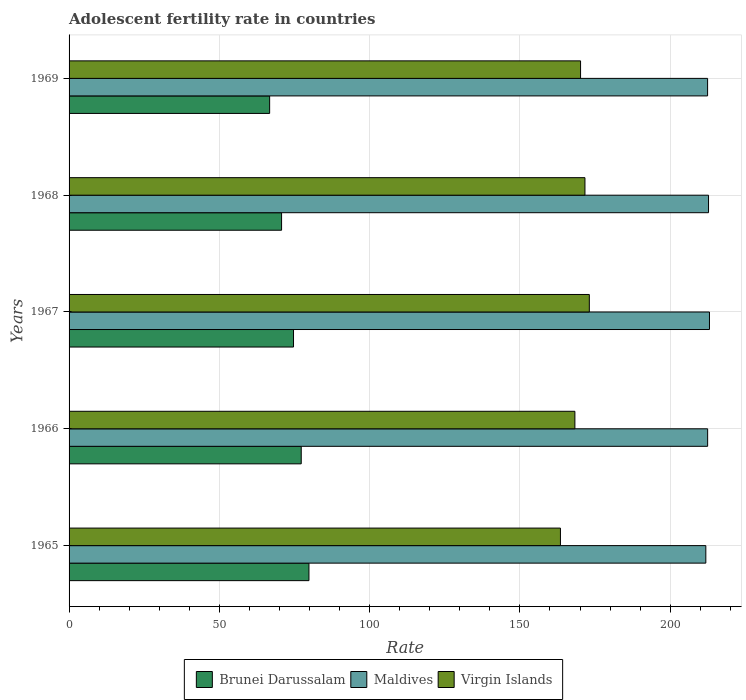Are the number of bars per tick equal to the number of legend labels?
Ensure brevity in your answer.  Yes. Are the number of bars on each tick of the Y-axis equal?
Give a very brief answer. Yes. How many bars are there on the 2nd tick from the bottom?
Give a very brief answer. 3. What is the label of the 1st group of bars from the top?
Offer a terse response. 1969. In how many cases, is the number of bars for a given year not equal to the number of legend labels?
Your answer should be very brief. 0. What is the adolescent fertility rate in Virgin Islands in 1965?
Your answer should be very brief. 163.49. Across all years, what is the maximum adolescent fertility rate in Maldives?
Give a very brief answer. 213.08. Across all years, what is the minimum adolescent fertility rate in Virgin Islands?
Give a very brief answer. 163.49. In which year was the adolescent fertility rate in Maldives maximum?
Offer a terse response. 1967. In which year was the adolescent fertility rate in Virgin Islands minimum?
Ensure brevity in your answer.  1965. What is the total adolescent fertility rate in Maldives in the graph?
Ensure brevity in your answer.  1062.65. What is the difference between the adolescent fertility rate in Maldives in 1965 and that in 1969?
Provide a succinct answer. -0.59. What is the difference between the adolescent fertility rate in Virgin Islands in 1967 and the adolescent fertility rate in Brunei Darussalam in 1968?
Ensure brevity in your answer.  102.4. What is the average adolescent fertility rate in Maldives per year?
Ensure brevity in your answer.  212.53. In the year 1966, what is the difference between the adolescent fertility rate in Brunei Darussalam and adolescent fertility rate in Virgin Islands?
Keep it short and to the point. -91.05. What is the ratio of the adolescent fertility rate in Maldives in 1966 to that in 1969?
Keep it short and to the point. 1. Is the adolescent fertility rate in Brunei Darussalam in 1965 less than that in 1966?
Your answer should be compact. No. Is the difference between the adolescent fertility rate in Brunei Darussalam in 1966 and 1969 greater than the difference between the adolescent fertility rate in Virgin Islands in 1966 and 1969?
Offer a terse response. Yes. What is the difference between the highest and the second highest adolescent fertility rate in Virgin Islands?
Ensure brevity in your answer.  1.46. What is the difference between the highest and the lowest adolescent fertility rate in Maldives?
Keep it short and to the point. 1.21. In how many years, is the adolescent fertility rate in Virgin Islands greater than the average adolescent fertility rate in Virgin Islands taken over all years?
Provide a succinct answer. 3. What does the 3rd bar from the top in 1969 represents?
Make the answer very short. Brunei Darussalam. What does the 2nd bar from the bottom in 1969 represents?
Keep it short and to the point. Maldives. Are all the bars in the graph horizontal?
Your response must be concise. Yes. How many years are there in the graph?
Provide a succinct answer. 5. Are the values on the major ticks of X-axis written in scientific E-notation?
Offer a terse response. No. Does the graph contain grids?
Keep it short and to the point. Yes. Where does the legend appear in the graph?
Your answer should be compact. Bottom center. How many legend labels are there?
Provide a succinct answer. 3. What is the title of the graph?
Make the answer very short. Adolescent fertility rate in countries. What is the label or title of the X-axis?
Your answer should be very brief. Rate. What is the label or title of the Y-axis?
Offer a terse response. Years. What is the Rate of Brunei Darussalam in 1965?
Keep it short and to the point. 79.82. What is the Rate in Maldives in 1965?
Your answer should be very brief. 211.87. What is the Rate of Virgin Islands in 1965?
Your answer should be compact. 163.49. What is the Rate of Brunei Darussalam in 1966?
Your response must be concise. 77.25. What is the Rate of Maldives in 1966?
Your answer should be compact. 212.47. What is the Rate in Virgin Islands in 1966?
Offer a terse response. 168.3. What is the Rate in Brunei Darussalam in 1967?
Your answer should be very brief. 74.68. What is the Rate of Maldives in 1967?
Provide a short and direct response. 213.08. What is the Rate in Virgin Islands in 1967?
Provide a succinct answer. 173.11. What is the Rate of Brunei Darussalam in 1968?
Give a very brief answer. 70.71. What is the Rate of Maldives in 1968?
Your response must be concise. 212.77. What is the Rate of Virgin Islands in 1968?
Offer a very short reply. 171.65. What is the Rate in Brunei Darussalam in 1969?
Keep it short and to the point. 66.74. What is the Rate of Maldives in 1969?
Your response must be concise. 212.46. What is the Rate of Virgin Islands in 1969?
Your response must be concise. 170.19. Across all years, what is the maximum Rate of Brunei Darussalam?
Keep it short and to the point. 79.82. Across all years, what is the maximum Rate of Maldives?
Your answer should be compact. 213.08. Across all years, what is the maximum Rate of Virgin Islands?
Make the answer very short. 173.11. Across all years, what is the minimum Rate of Brunei Darussalam?
Offer a very short reply. 66.74. Across all years, what is the minimum Rate of Maldives?
Your answer should be compact. 211.87. Across all years, what is the minimum Rate in Virgin Islands?
Keep it short and to the point. 163.49. What is the total Rate in Brunei Darussalam in the graph?
Give a very brief answer. 369.19. What is the total Rate of Maldives in the graph?
Your answer should be compact. 1062.65. What is the total Rate of Virgin Islands in the graph?
Your answer should be compact. 846.74. What is the difference between the Rate in Brunei Darussalam in 1965 and that in 1966?
Give a very brief answer. 2.57. What is the difference between the Rate in Maldives in 1965 and that in 1966?
Provide a succinct answer. -0.61. What is the difference between the Rate of Virgin Islands in 1965 and that in 1966?
Provide a short and direct response. -4.81. What is the difference between the Rate of Brunei Darussalam in 1965 and that in 1967?
Your answer should be very brief. 5.13. What is the difference between the Rate of Maldives in 1965 and that in 1967?
Offer a very short reply. -1.21. What is the difference between the Rate in Virgin Islands in 1965 and that in 1967?
Provide a succinct answer. -9.62. What is the difference between the Rate in Brunei Darussalam in 1965 and that in 1968?
Ensure brevity in your answer.  9.11. What is the difference between the Rate of Maldives in 1965 and that in 1968?
Your answer should be very brief. -0.9. What is the difference between the Rate of Virgin Islands in 1965 and that in 1968?
Make the answer very short. -8.16. What is the difference between the Rate of Brunei Darussalam in 1965 and that in 1969?
Your answer should be very brief. 13.08. What is the difference between the Rate of Maldives in 1965 and that in 1969?
Offer a terse response. -0.59. What is the difference between the Rate of Virgin Islands in 1965 and that in 1969?
Give a very brief answer. -6.7. What is the difference between the Rate of Brunei Darussalam in 1966 and that in 1967?
Make the answer very short. 2.57. What is the difference between the Rate of Maldives in 1966 and that in 1967?
Provide a short and direct response. -0.61. What is the difference between the Rate in Virgin Islands in 1966 and that in 1967?
Offer a terse response. -4.81. What is the difference between the Rate of Brunei Darussalam in 1966 and that in 1968?
Give a very brief answer. 6.54. What is the difference between the Rate in Maldives in 1966 and that in 1968?
Provide a succinct answer. -0.3. What is the difference between the Rate in Virgin Islands in 1966 and that in 1968?
Offer a very short reply. -3.35. What is the difference between the Rate in Brunei Darussalam in 1966 and that in 1969?
Provide a succinct answer. 10.51. What is the difference between the Rate in Maldives in 1966 and that in 1969?
Your answer should be very brief. 0.02. What is the difference between the Rate in Virgin Islands in 1966 and that in 1969?
Your answer should be compact. -1.89. What is the difference between the Rate in Brunei Darussalam in 1967 and that in 1968?
Ensure brevity in your answer.  3.97. What is the difference between the Rate in Maldives in 1967 and that in 1968?
Keep it short and to the point. 0.31. What is the difference between the Rate of Virgin Islands in 1967 and that in 1968?
Make the answer very short. 1.46. What is the difference between the Rate in Brunei Darussalam in 1967 and that in 1969?
Give a very brief answer. 7.94. What is the difference between the Rate of Maldives in 1967 and that in 1969?
Your response must be concise. 0.62. What is the difference between the Rate in Virgin Islands in 1967 and that in 1969?
Provide a succinct answer. 2.92. What is the difference between the Rate in Brunei Darussalam in 1968 and that in 1969?
Your response must be concise. 3.97. What is the difference between the Rate in Maldives in 1968 and that in 1969?
Your answer should be very brief. 0.31. What is the difference between the Rate in Virgin Islands in 1968 and that in 1969?
Give a very brief answer. 1.46. What is the difference between the Rate in Brunei Darussalam in 1965 and the Rate in Maldives in 1966?
Provide a short and direct response. -132.66. What is the difference between the Rate of Brunei Darussalam in 1965 and the Rate of Virgin Islands in 1966?
Your answer should be very brief. -88.48. What is the difference between the Rate of Maldives in 1965 and the Rate of Virgin Islands in 1966?
Keep it short and to the point. 43.57. What is the difference between the Rate in Brunei Darussalam in 1965 and the Rate in Maldives in 1967?
Offer a very short reply. -133.26. What is the difference between the Rate of Brunei Darussalam in 1965 and the Rate of Virgin Islands in 1967?
Provide a succinct answer. -93.29. What is the difference between the Rate of Maldives in 1965 and the Rate of Virgin Islands in 1967?
Ensure brevity in your answer.  38.76. What is the difference between the Rate of Brunei Darussalam in 1965 and the Rate of Maldives in 1968?
Your response must be concise. -132.95. What is the difference between the Rate in Brunei Darussalam in 1965 and the Rate in Virgin Islands in 1968?
Offer a terse response. -91.83. What is the difference between the Rate in Maldives in 1965 and the Rate in Virgin Islands in 1968?
Ensure brevity in your answer.  40.22. What is the difference between the Rate in Brunei Darussalam in 1965 and the Rate in Maldives in 1969?
Give a very brief answer. -132.64. What is the difference between the Rate of Brunei Darussalam in 1965 and the Rate of Virgin Islands in 1969?
Your answer should be very brief. -90.37. What is the difference between the Rate of Maldives in 1965 and the Rate of Virgin Islands in 1969?
Your answer should be very brief. 41.68. What is the difference between the Rate of Brunei Darussalam in 1966 and the Rate of Maldives in 1967?
Your response must be concise. -135.83. What is the difference between the Rate of Brunei Darussalam in 1966 and the Rate of Virgin Islands in 1967?
Your answer should be very brief. -95.86. What is the difference between the Rate in Maldives in 1966 and the Rate in Virgin Islands in 1967?
Your answer should be compact. 39.37. What is the difference between the Rate of Brunei Darussalam in 1966 and the Rate of Maldives in 1968?
Your response must be concise. -135.52. What is the difference between the Rate in Brunei Darussalam in 1966 and the Rate in Virgin Islands in 1968?
Give a very brief answer. -94.4. What is the difference between the Rate in Maldives in 1966 and the Rate in Virgin Islands in 1968?
Offer a terse response. 40.82. What is the difference between the Rate in Brunei Darussalam in 1966 and the Rate in Maldives in 1969?
Your answer should be very brief. -135.21. What is the difference between the Rate in Brunei Darussalam in 1966 and the Rate in Virgin Islands in 1969?
Ensure brevity in your answer.  -92.94. What is the difference between the Rate in Maldives in 1966 and the Rate in Virgin Islands in 1969?
Offer a terse response. 42.28. What is the difference between the Rate of Brunei Darussalam in 1967 and the Rate of Maldives in 1968?
Make the answer very short. -138.09. What is the difference between the Rate in Brunei Darussalam in 1967 and the Rate in Virgin Islands in 1968?
Keep it short and to the point. -96.97. What is the difference between the Rate of Maldives in 1967 and the Rate of Virgin Islands in 1968?
Provide a short and direct response. 41.43. What is the difference between the Rate in Brunei Darussalam in 1967 and the Rate in Maldives in 1969?
Your response must be concise. -137.78. What is the difference between the Rate in Brunei Darussalam in 1967 and the Rate in Virgin Islands in 1969?
Your response must be concise. -95.51. What is the difference between the Rate of Maldives in 1967 and the Rate of Virgin Islands in 1969?
Your response must be concise. 42.89. What is the difference between the Rate of Brunei Darussalam in 1968 and the Rate of Maldives in 1969?
Your answer should be very brief. -141.75. What is the difference between the Rate of Brunei Darussalam in 1968 and the Rate of Virgin Islands in 1969?
Give a very brief answer. -99.48. What is the difference between the Rate of Maldives in 1968 and the Rate of Virgin Islands in 1969?
Provide a short and direct response. 42.58. What is the average Rate of Brunei Darussalam per year?
Provide a short and direct response. 73.84. What is the average Rate of Maldives per year?
Offer a very short reply. 212.53. What is the average Rate in Virgin Islands per year?
Make the answer very short. 169.35. In the year 1965, what is the difference between the Rate of Brunei Darussalam and Rate of Maldives?
Make the answer very short. -132.05. In the year 1965, what is the difference between the Rate of Brunei Darussalam and Rate of Virgin Islands?
Provide a short and direct response. -83.68. In the year 1965, what is the difference between the Rate of Maldives and Rate of Virgin Islands?
Offer a terse response. 48.37. In the year 1966, what is the difference between the Rate in Brunei Darussalam and Rate in Maldives?
Offer a very short reply. -135.22. In the year 1966, what is the difference between the Rate in Brunei Darussalam and Rate in Virgin Islands?
Offer a terse response. -91.05. In the year 1966, what is the difference between the Rate of Maldives and Rate of Virgin Islands?
Your answer should be very brief. 44.17. In the year 1967, what is the difference between the Rate in Brunei Darussalam and Rate in Maldives?
Provide a short and direct response. -138.4. In the year 1967, what is the difference between the Rate of Brunei Darussalam and Rate of Virgin Islands?
Make the answer very short. -98.43. In the year 1967, what is the difference between the Rate of Maldives and Rate of Virgin Islands?
Make the answer very short. 39.97. In the year 1968, what is the difference between the Rate in Brunei Darussalam and Rate in Maldives?
Ensure brevity in your answer.  -142.06. In the year 1968, what is the difference between the Rate in Brunei Darussalam and Rate in Virgin Islands?
Provide a succinct answer. -100.94. In the year 1968, what is the difference between the Rate of Maldives and Rate of Virgin Islands?
Ensure brevity in your answer.  41.12. In the year 1969, what is the difference between the Rate in Brunei Darussalam and Rate in Maldives?
Keep it short and to the point. -145.72. In the year 1969, what is the difference between the Rate of Brunei Darussalam and Rate of Virgin Islands?
Provide a short and direct response. -103.45. In the year 1969, what is the difference between the Rate in Maldives and Rate in Virgin Islands?
Give a very brief answer. 42.27. What is the ratio of the Rate in Brunei Darussalam in 1965 to that in 1966?
Offer a terse response. 1.03. What is the ratio of the Rate of Virgin Islands in 1965 to that in 1966?
Keep it short and to the point. 0.97. What is the ratio of the Rate of Brunei Darussalam in 1965 to that in 1967?
Provide a short and direct response. 1.07. What is the ratio of the Rate in Maldives in 1965 to that in 1967?
Ensure brevity in your answer.  0.99. What is the ratio of the Rate in Virgin Islands in 1965 to that in 1967?
Offer a terse response. 0.94. What is the ratio of the Rate in Brunei Darussalam in 1965 to that in 1968?
Your answer should be very brief. 1.13. What is the ratio of the Rate in Virgin Islands in 1965 to that in 1968?
Provide a succinct answer. 0.95. What is the ratio of the Rate of Brunei Darussalam in 1965 to that in 1969?
Give a very brief answer. 1.2. What is the ratio of the Rate of Maldives in 1965 to that in 1969?
Give a very brief answer. 1. What is the ratio of the Rate of Virgin Islands in 1965 to that in 1969?
Your answer should be very brief. 0.96. What is the ratio of the Rate in Brunei Darussalam in 1966 to that in 1967?
Provide a succinct answer. 1.03. What is the ratio of the Rate in Maldives in 1966 to that in 1967?
Make the answer very short. 1. What is the ratio of the Rate of Virgin Islands in 1966 to that in 1967?
Provide a short and direct response. 0.97. What is the ratio of the Rate in Brunei Darussalam in 1966 to that in 1968?
Your answer should be very brief. 1.09. What is the ratio of the Rate of Virgin Islands in 1966 to that in 1968?
Give a very brief answer. 0.98. What is the ratio of the Rate of Brunei Darussalam in 1966 to that in 1969?
Offer a very short reply. 1.16. What is the ratio of the Rate of Virgin Islands in 1966 to that in 1969?
Offer a very short reply. 0.99. What is the ratio of the Rate in Brunei Darussalam in 1967 to that in 1968?
Offer a terse response. 1.06. What is the ratio of the Rate of Maldives in 1967 to that in 1968?
Make the answer very short. 1. What is the ratio of the Rate in Virgin Islands in 1967 to that in 1968?
Make the answer very short. 1.01. What is the ratio of the Rate in Brunei Darussalam in 1967 to that in 1969?
Your response must be concise. 1.12. What is the ratio of the Rate of Virgin Islands in 1967 to that in 1969?
Your answer should be very brief. 1.02. What is the ratio of the Rate in Brunei Darussalam in 1968 to that in 1969?
Make the answer very short. 1.06. What is the ratio of the Rate in Virgin Islands in 1968 to that in 1969?
Your answer should be compact. 1.01. What is the difference between the highest and the second highest Rate of Brunei Darussalam?
Provide a succinct answer. 2.57. What is the difference between the highest and the second highest Rate in Maldives?
Keep it short and to the point. 0.31. What is the difference between the highest and the second highest Rate in Virgin Islands?
Offer a terse response. 1.46. What is the difference between the highest and the lowest Rate of Brunei Darussalam?
Ensure brevity in your answer.  13.08. What is the difference between the highest and the lowest Rate in Maldives?
Make the answer very short. 1.21. What is the difference between the highest and the lowest Rate of Virgin Islands?
Ensure brevity in your answer.  9.62. 